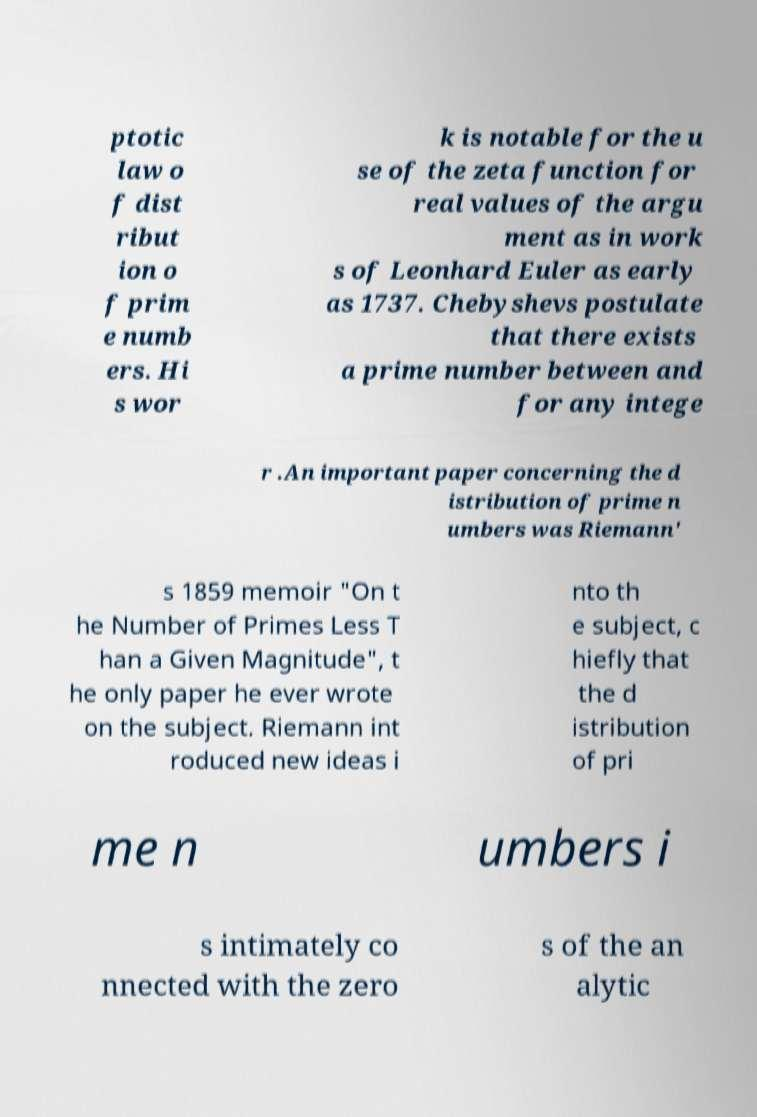For documentation purposes, I need the text within this image transcribed. Could you provide that? ptotic law o f dist ribut ion o f prim e numb ers. Hi s wor k is notable for the u se of the zeta function for real values of the argu ment as in work s of Leonhard Euler as early as 1737. Chebyshevs postulate that there exists a prime number between and for any intege r .An important paper concerning the d istribution of prime n umbers was Riemann' s 1859 memoir "On t he Number of Primes Less T han a Given Magnitude", t he only paper he ever wrote on the subject. Riemann int roduced new ideas i nto th e subject, c hiefly that the d istribution of pri me n umbers i s intimately co nnected with the zero s of the an alytic 